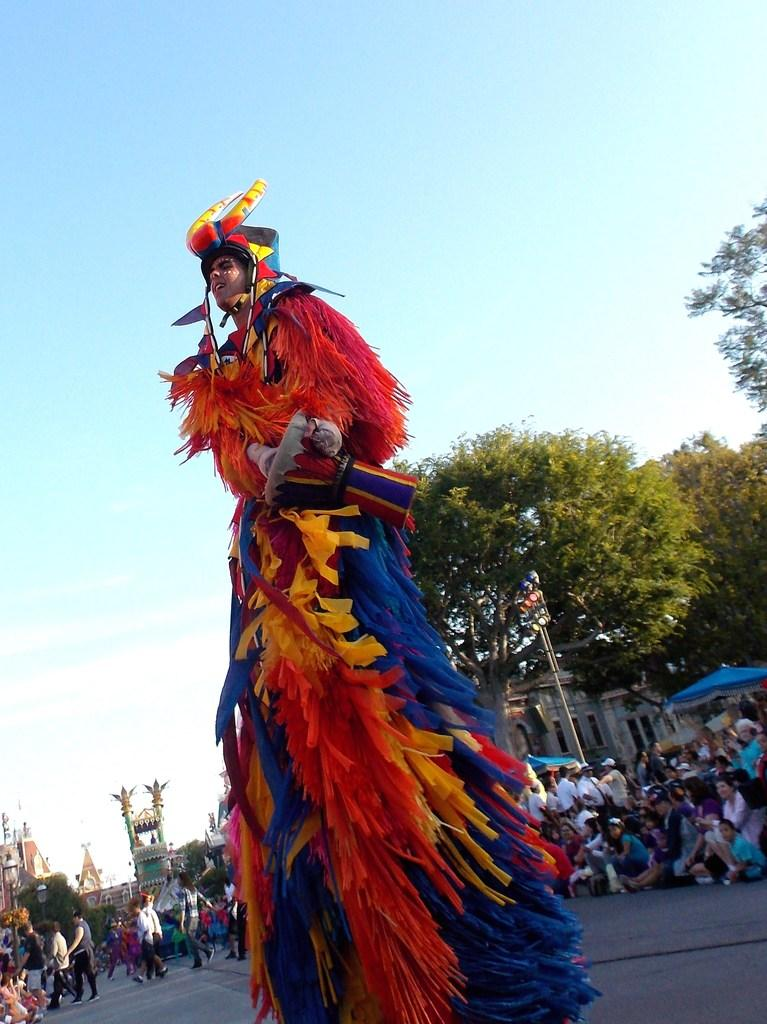What is the person in the image wearing? The person in the image is wearing a costume. What can be seen in the background of the image? There is a crowd, trees, buildings, and the sky visible in the background of the image. How many elements can be identified in the background of the image? There are four elements in the background of the image: a crowd, trees, buildings, and the sky. Is there a river flowing through the background of the image? There is no river visible in the background of the image. What type of holiday is being celebrated in the image? There is no indication of a holiday being celebrated in the image. 